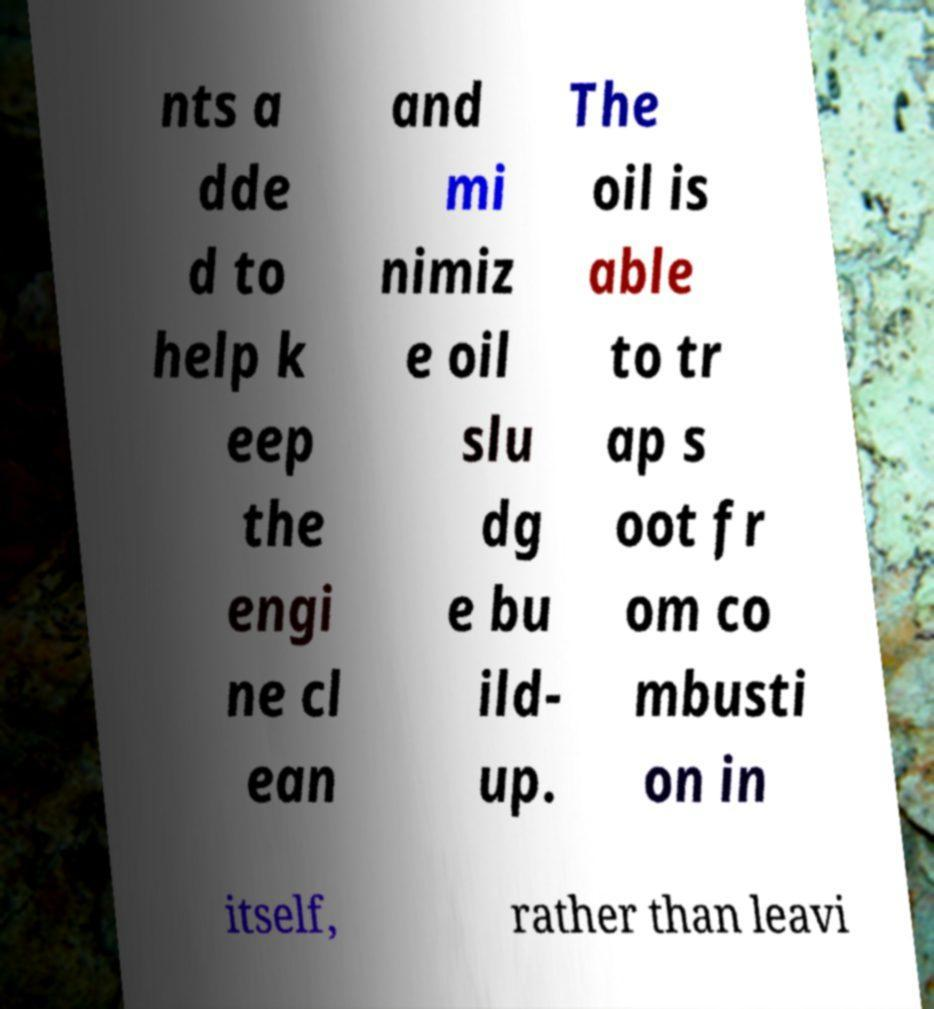Can you accurately transcribe the text from the provided image for me? nts a dde d to help k eep the engi ne cl ean and mi nimiz e oil slu dg e bu ild- up. The oil is able to tr ap s oot fr om co mbusti on in itself, rather than leavi 